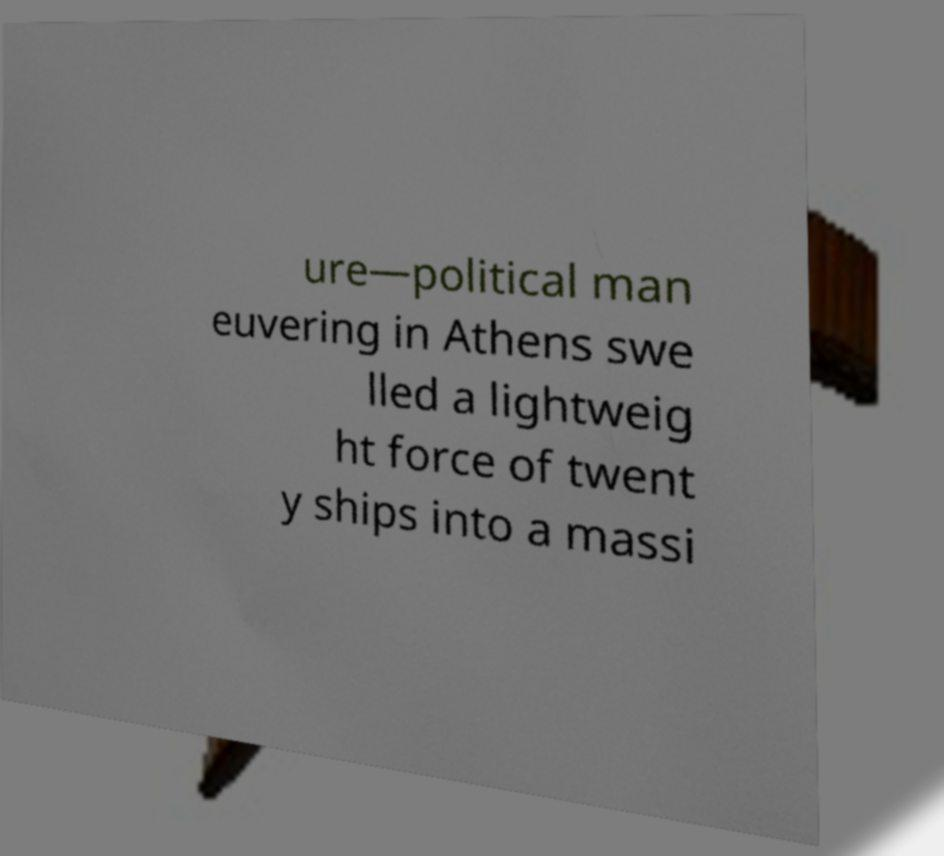There's text embedded in this image that I need extracted. Can you transcribe it verbatim? ure—political man euvering in Athens swe lled a lightweig ht force of twent y ships into a massi 